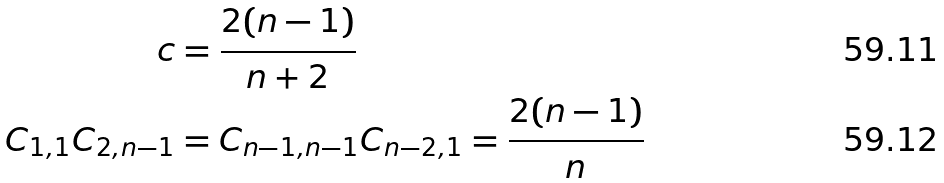Convert formula to latex. <formula><loc_0><loc_0><loc_500><loc_500>c & = \frac { 2 ( n - 1 ) } { n + 2 } \\ C _ { 1 , 1 } C _ { 2 , n - 1 } & = C _ { n - 1 , n - 1 } C _ { n - 2 , 1 } = \frac { 2 ( n - 1 ) } { n }</formula> 